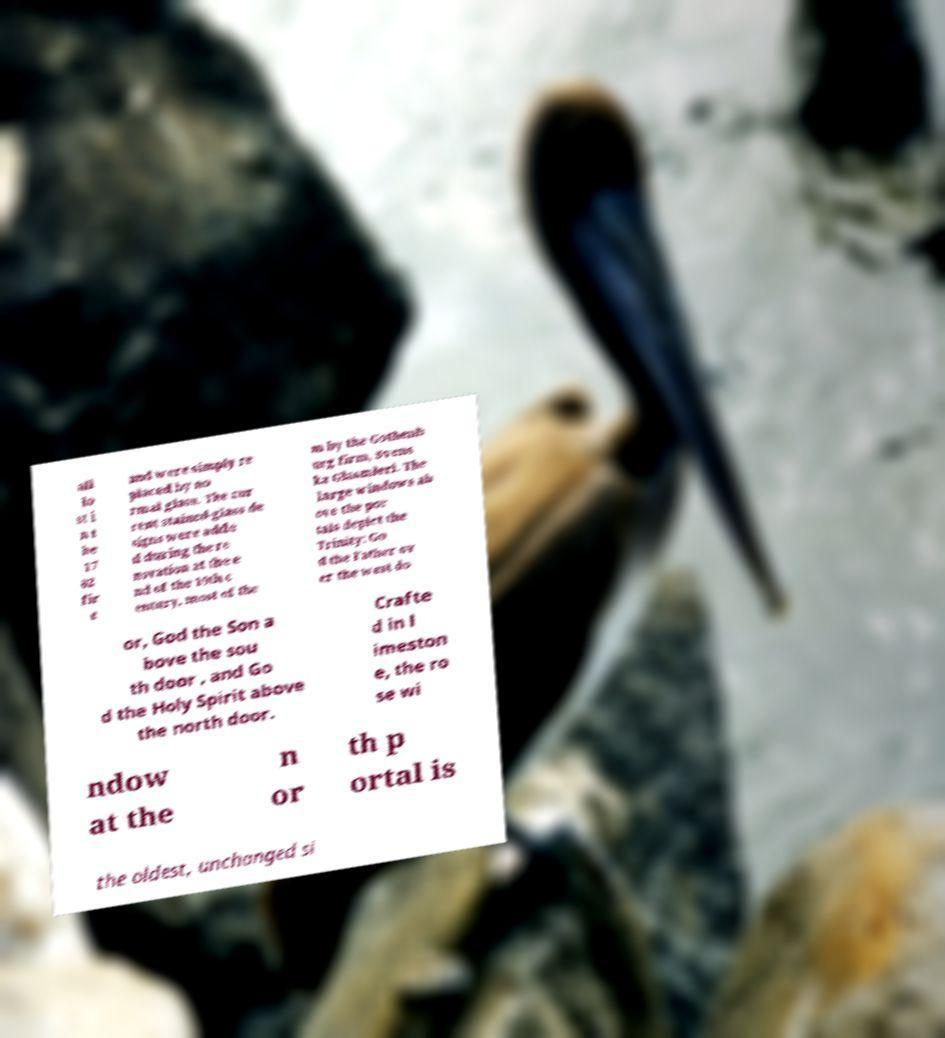I need the written content from this picture converted into text. Can you do that? all lo st i n t he 17 02 fir e and were simply re placed by no rmal glass. The cur rent stained-glass de signs were adde d during the re novation at the e nd of the 19th c entury, most of the m by the Gothenb urg firm, Svens ka Glasmleri. The large windows ab ove the por tals depict the Trinity: Go d the Father ov er the west do or, God the Son a bove the sou th door , and Go d the Holy Spirit above the north door. Crafte d in l imeston e, the ro se wi ndow at the n or th p ortal is the oldest, unchanged si 